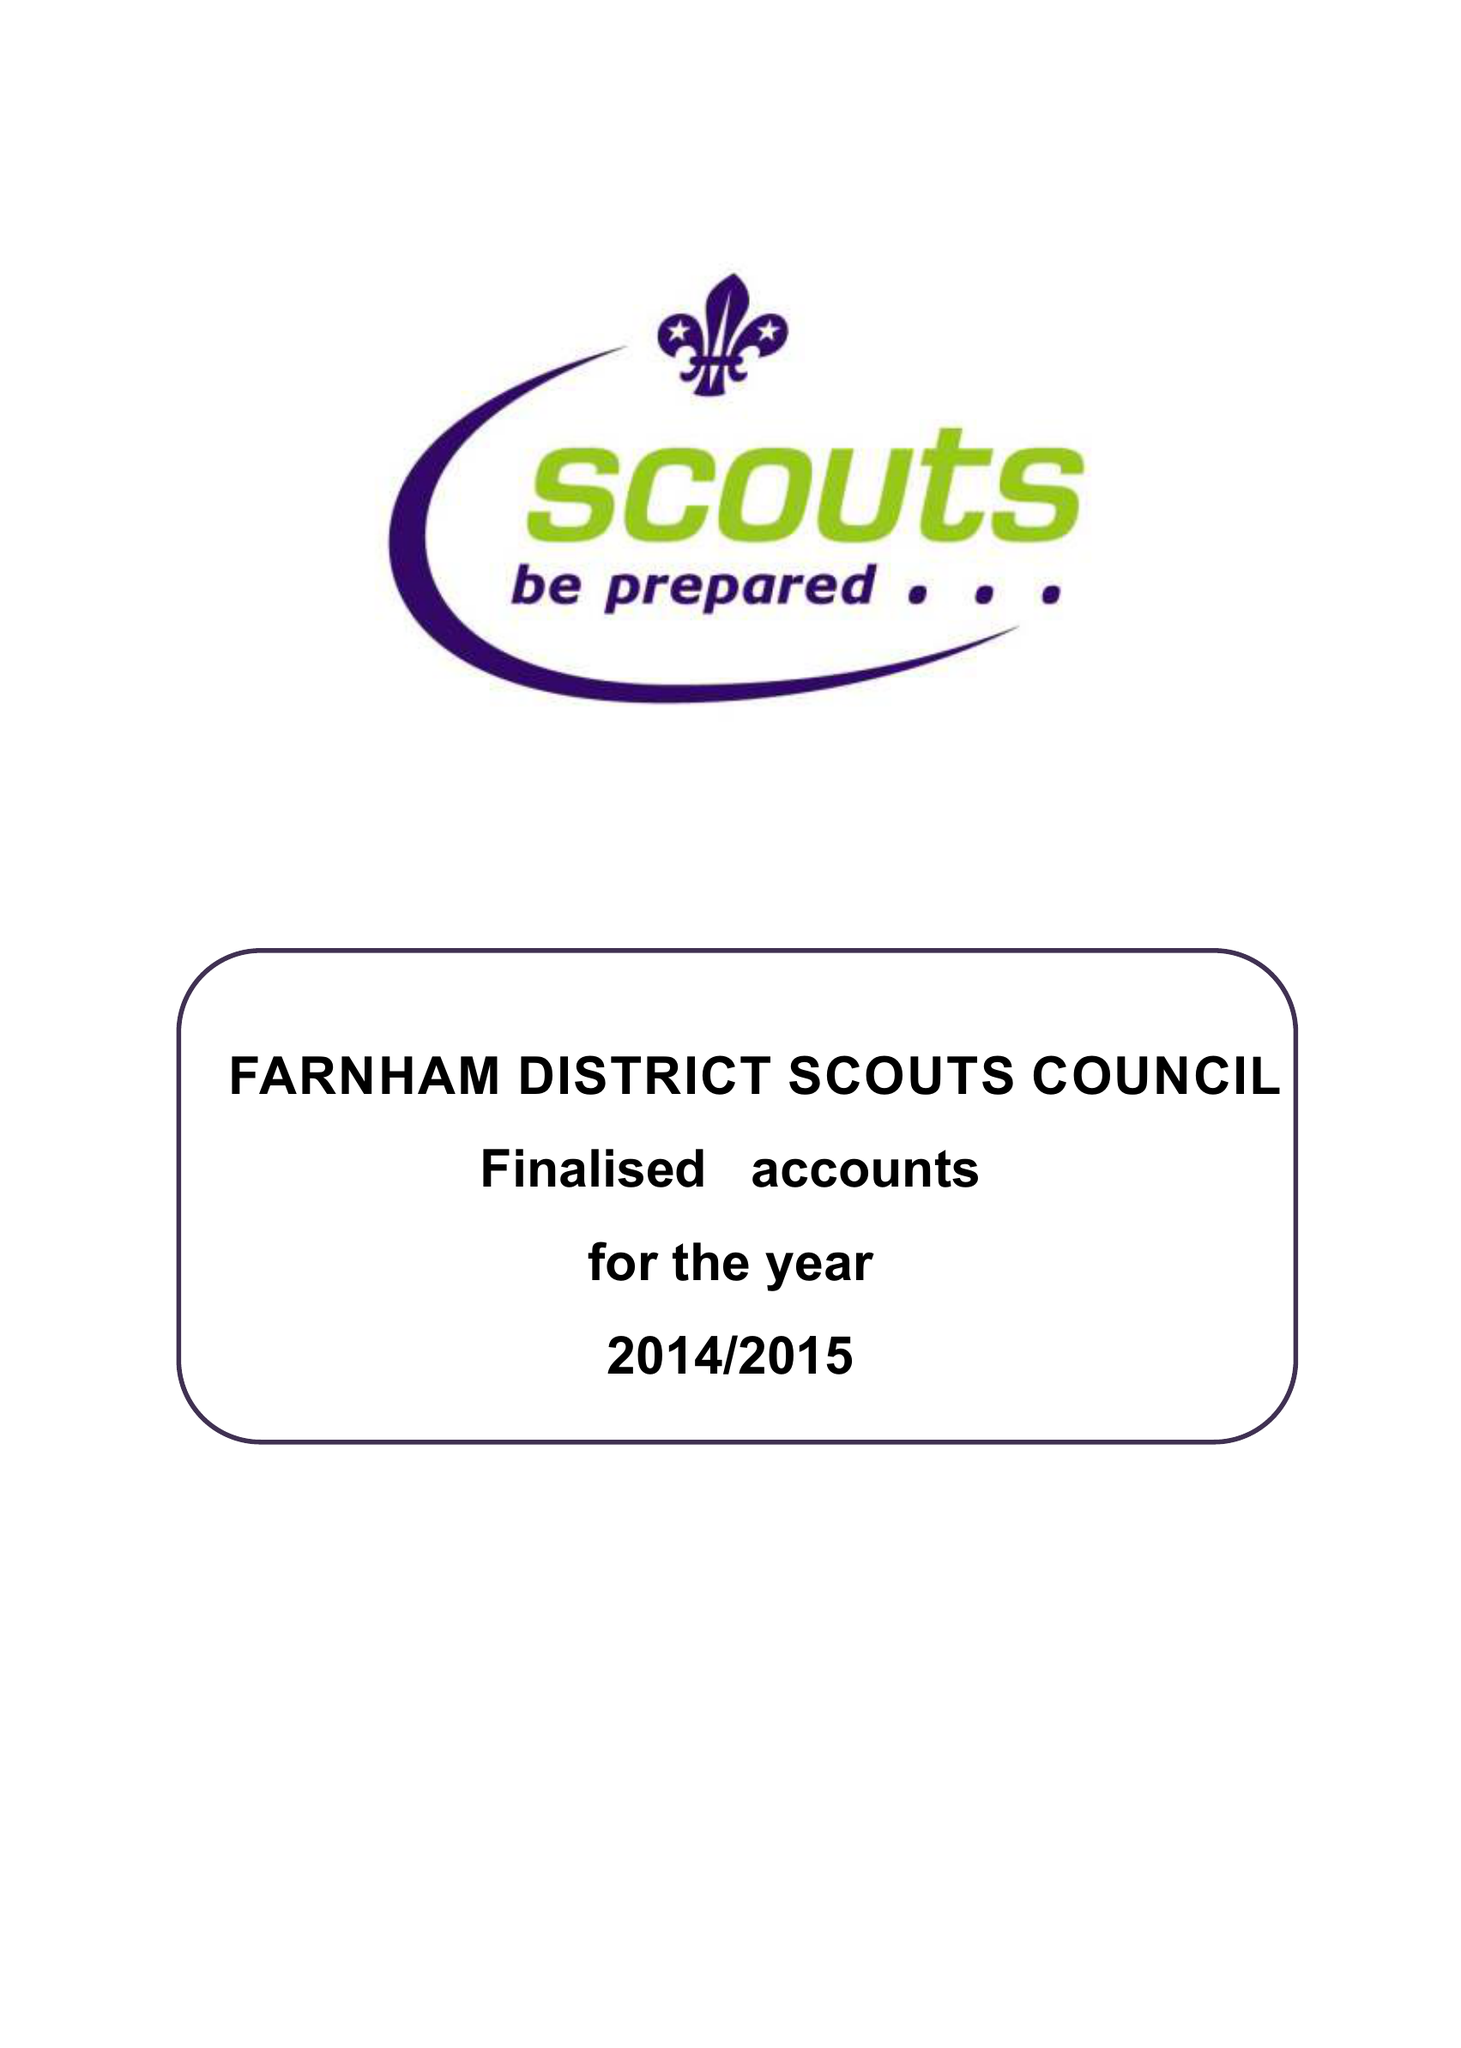What is the value for the spending_annually_in_british_pounds?
Answer the question using a single word or phrase. 134355.00 